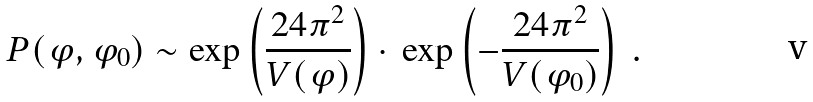Convert formula to latex. <formula><loc_0><loc_0><loc_500><loc_500>P ( \varphi , \varphi _ { 0 } ) \sim \exp \left ( { \frac { 2 4 \pi ^ { 2 } } { V ( \varphi ) } } \right ) \cdot \, \exp \left ( - { \frac { 2 4 \pi ^ { 2 } } { V ( \varphi _ { 0 } ) } } \right ) \ .</formula> 